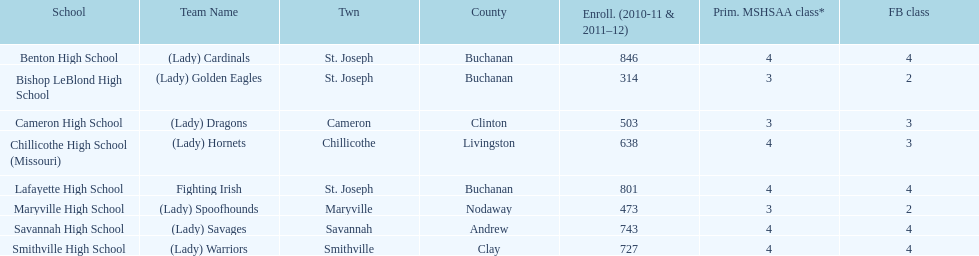Which schools are in the same town as bishop leblond? Benton High School, Lafayette High School. 